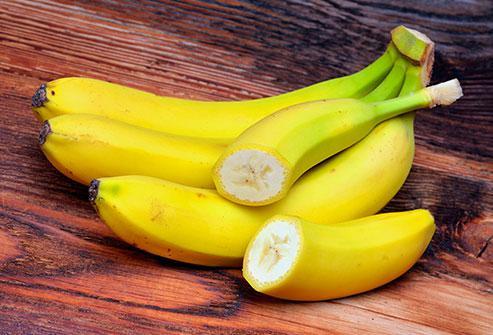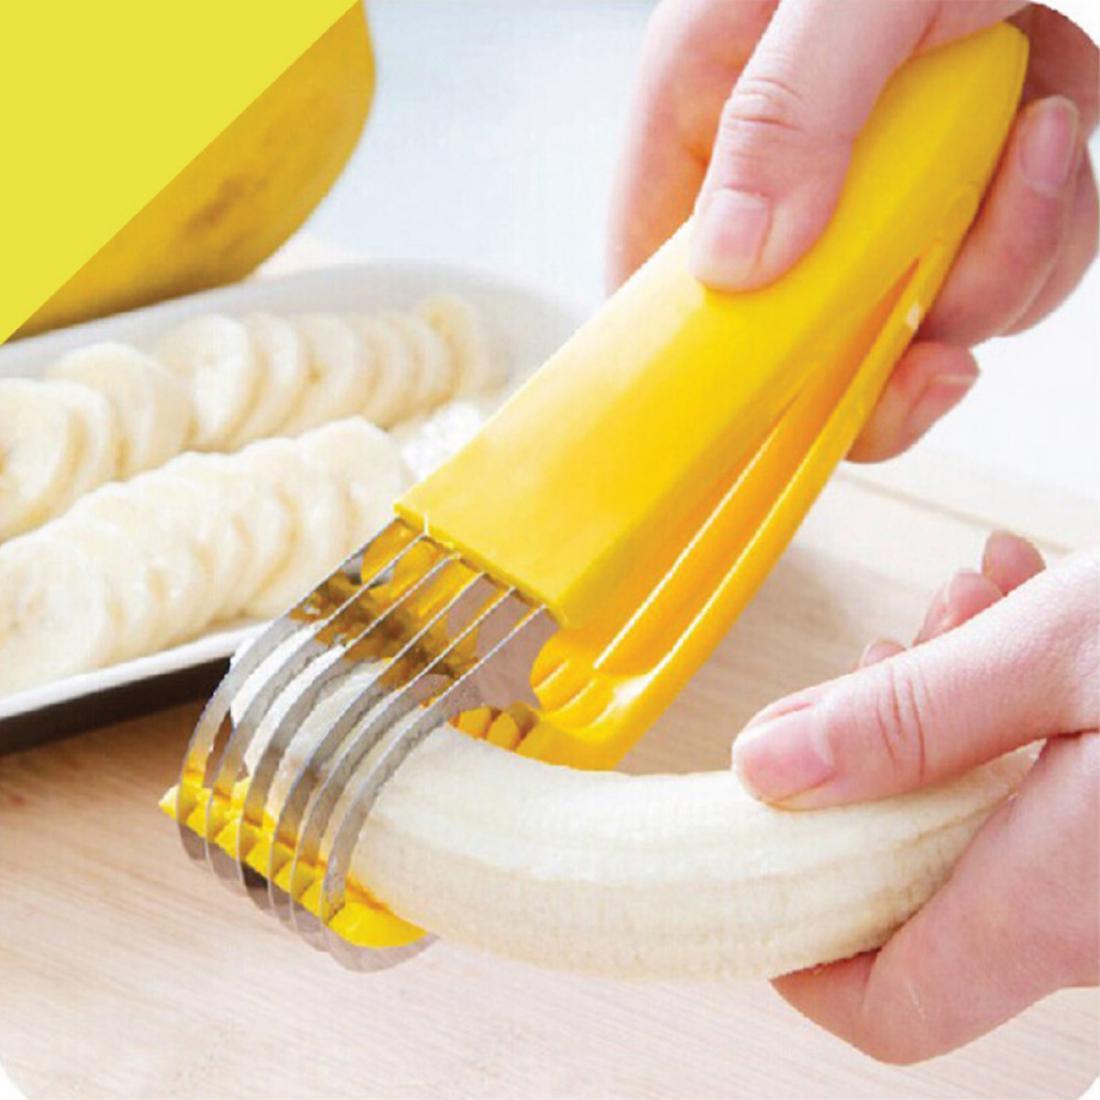The first image is the image on the left, the second image is the image on the right. Analyze the images presented: Is the assertion "Only fake bananas shown." valid? Answer yes or no. No. The first image is the image on the left, the second image is the image on the right. Evaluate the accuracy of this statement regarding the images: "Someone is placing a banana in a banana slicer in at least one of the pictures.". Is it true? Answer yes or no. Yes. 